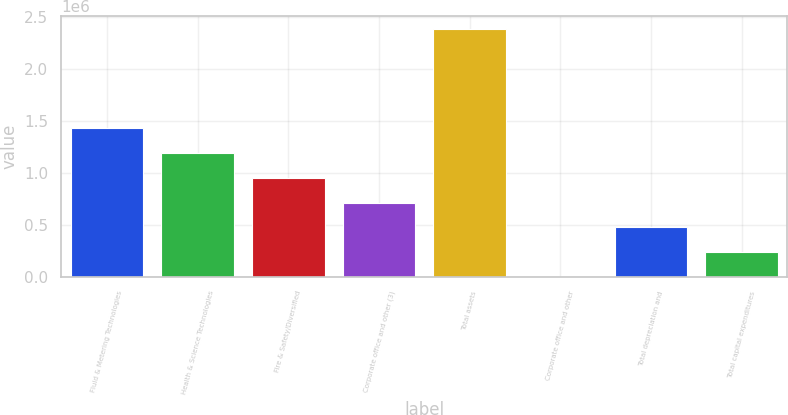Convert chart to OTSL. <chart><loc_0><loc_0><loc_500><loc_500><bar_chart><fcel>Fluid & Metering Technologies<fcel>Health & Science Technologies<fcel>Fire & Safety/Diversified<fcel>Corporate office and other (3)<fcel>Total assets<fcel>Corporate office and other<fcel>Total depreciation and<fcel>Total capital expenditures<nl><fcel>1.42915e+06<fcel>1.19101e+06<fcel>952872<fcel>714735<fcel>2.3817e+06<fcel>324<fcel>476598<fcel>238461<nl></chart> 